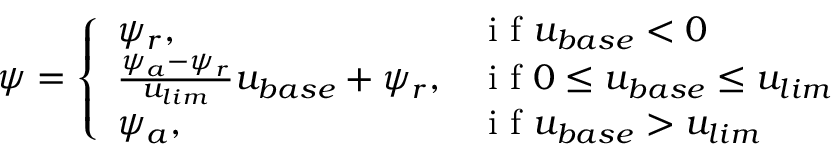<formula> <loc_0><loc_0><loc_500><loc_500>\psi = \left \{ \begin{array} { l l } { \psi _ { r } , } & { i f u _ { b a s e } < 0 } \\ { \frac { \psi _ { a } - \psi _ { r } } { u _ { l i m } } u _ { b a s e } + \psi _ { r } , } & { i f 0 \leq u _ { b a s e } \leq u _ { l i m } } \\ { \psi _ { a } , } & { i f u _ { b a s e } > u _ { l i m } } \end{array}</formula> 